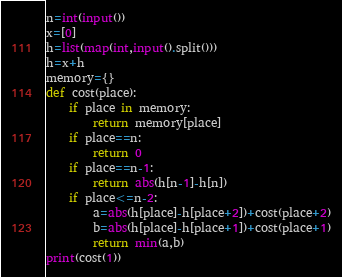Convert code to text. <code><loc_0><loc_0><loc_500><loc_500><_Python_>n=int(input())
x=[0]
h=list(map(int,input().split()))
h=x+h
memory={}
def cost(place):
    if place in memory:
        return memory[place]
    if place==n:
        return 0
    if place==n-1:
        return abs(h[n-1]-h[n])
    if place<=n-2:
        a=abs(h[place]-h[place+2])+cost(place+2)
        b=abs(h[place]-h[place+1])+cost(place+1)
        return min(a,b)
print(cost(1))
</code> 